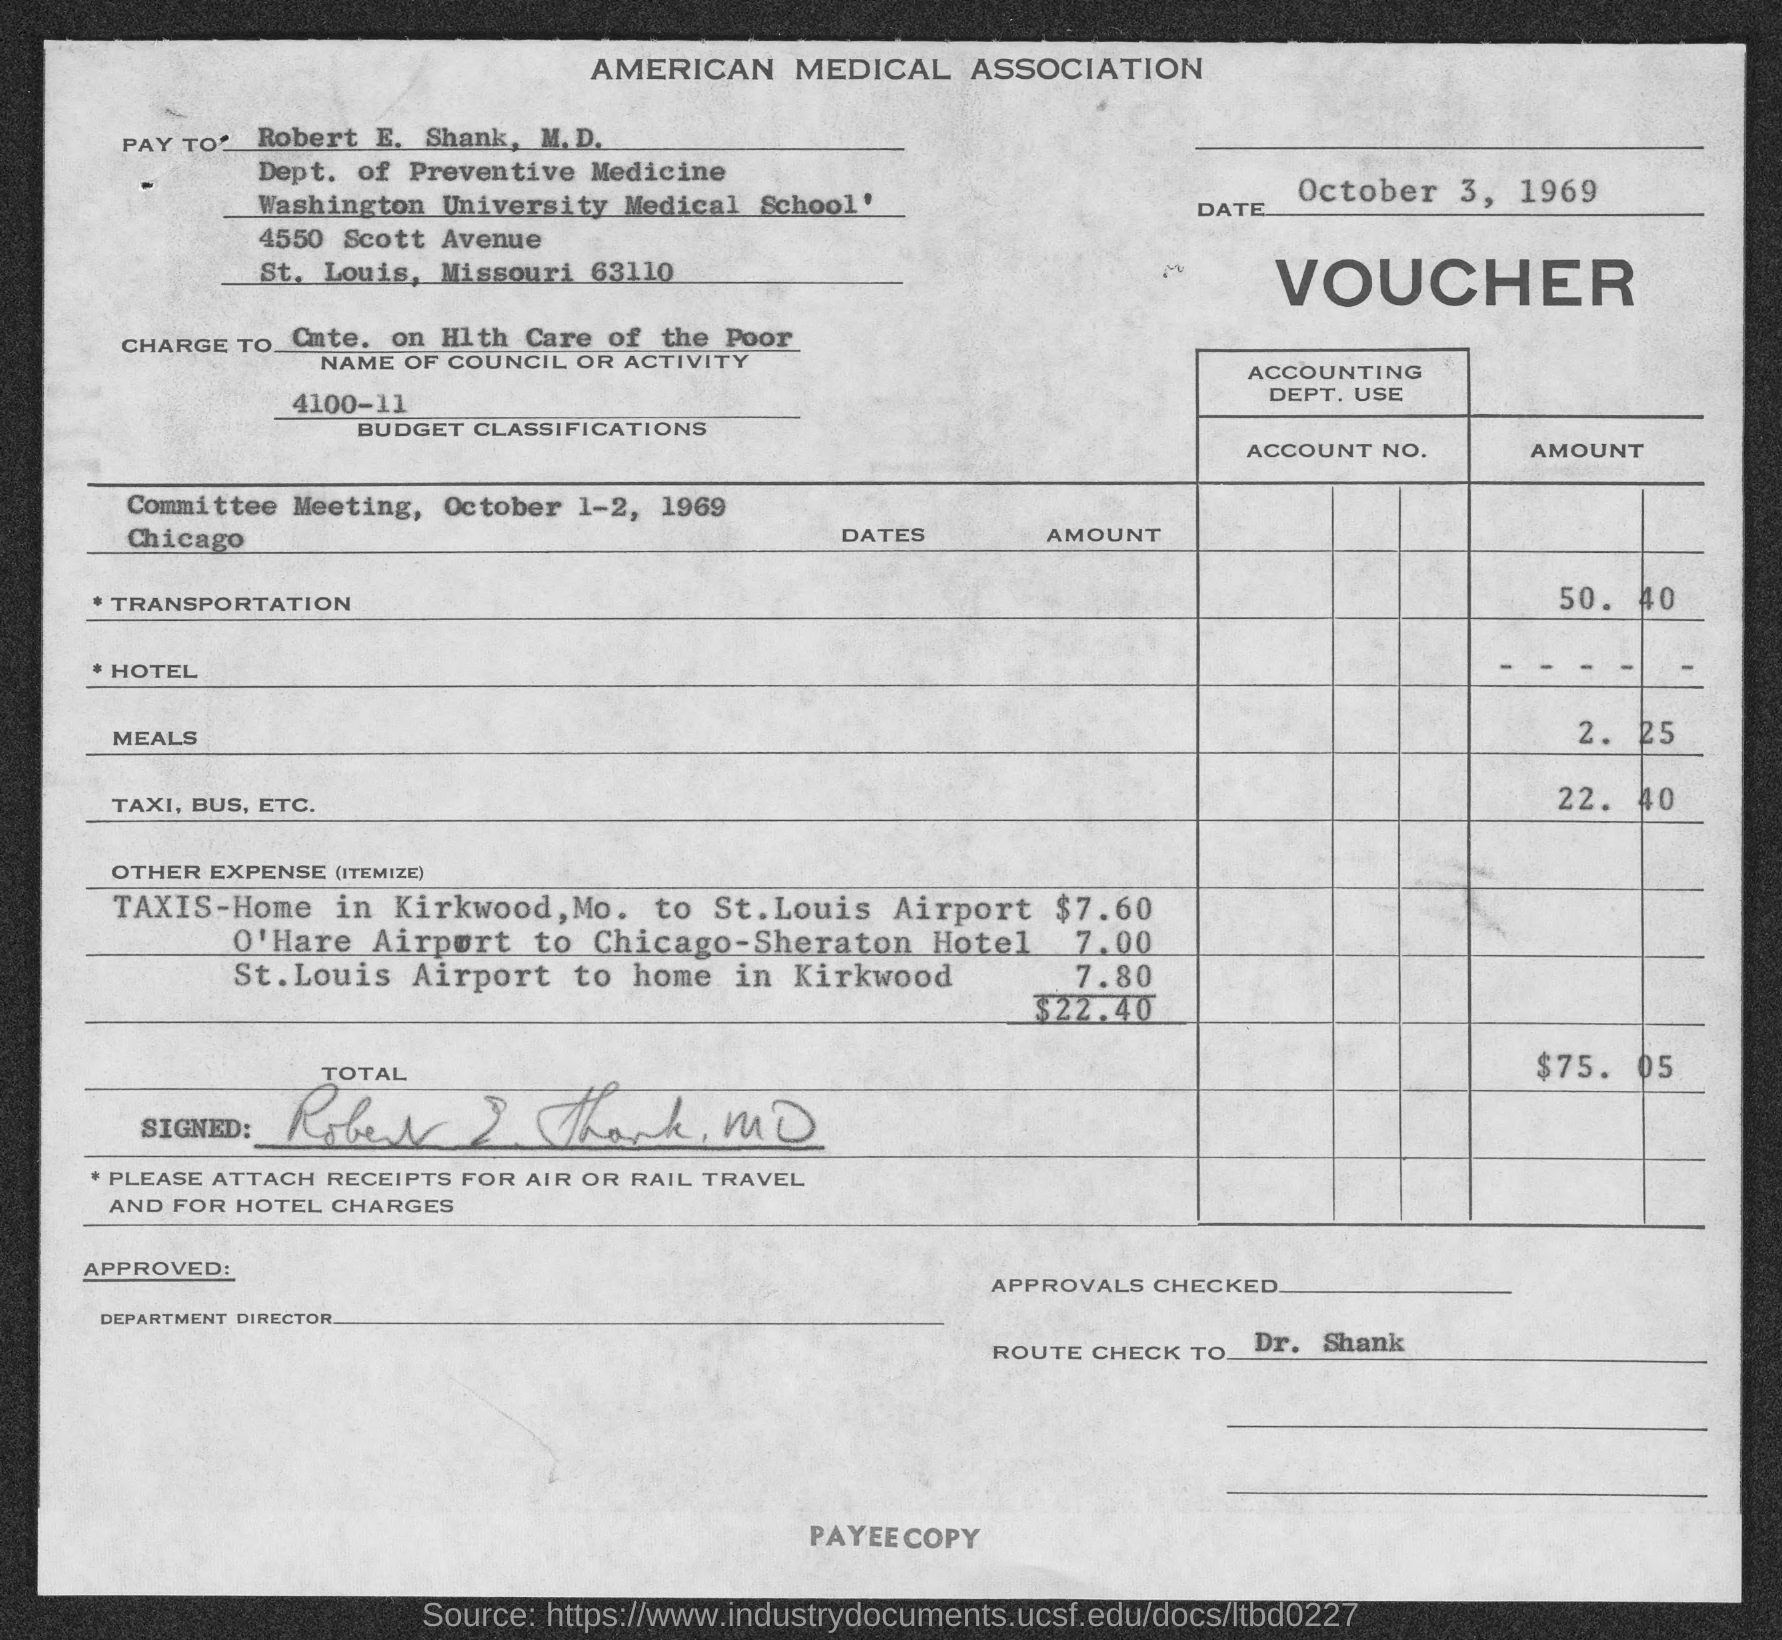What is the date mentioned in the given page ?
Offer a terse response. October 3, 1969. What is the name of the association mentioned in the given form ?
Your response must be concise. AMERICAN MEDICAL ASSOCIATION. What is the amount for transportation ?
Offer a very short reply. 50.40. What is the amount for meals ?
Ensure brevity in your answer.  2.25. What is the amount for taxi,bus,etc. ?
Your response must be concise. 22.40. What is the amount of other expense ?
Make the answer very short. $22.40. What is the total amount mentioned in the given voucher ?
Provide a short and direct response. 75. 05. To whom the voucher has to be paid ?
Ensure brevity in your answer.  Robert E. Shank, M.D. What is the name of the department mentioned in the given form ?
Offer a very short reply. Dept. of Preventive  Medicine. What is the name of the university mentioned in the given form ?
Your answer should be compact. Washington University. 